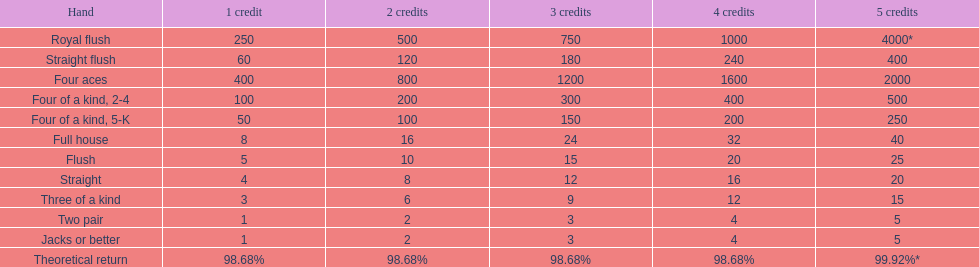In super aces, which hand is the most superior? Royal flush. 